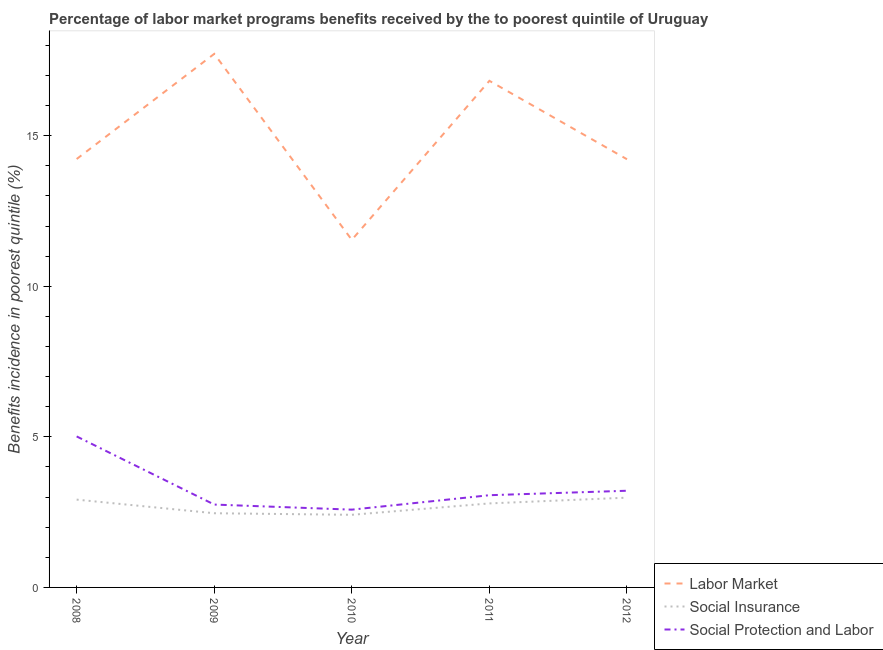How many different coloured lines are there?
Offer a terse response. 3. Does the line corresponding to percentage of benefits received due to labor market programs intersect with the line corresponding to percentage of benefits received due to social insurance programs?
Provide a succinct answer. No. What is the percentage of benefits received due to labor market programs in 2009?
Make the answer very short. 17.72. Across all years, what is the maximum percentage of benefits received due to social protection programs?
Give a very brief answer. 5.02. Across all years, what is the minimum percentage of benefits received due to labor market programs?
Your response must be concise. 11.54. What is the total percentage of benefits received due to labor market programs in the graph?
Make the answer very short. 74.54. What is the difference between the percentage of benefits received due to social insurance programs in 2009 and that in 2012?
Make the answer very short. -0.52. What is the difference between the percentage of benefits received due to labor market programs in 2008 and the percentage of benefits received due to social insurance programs in 2009?
Offer a very short reply. 11.76. What is the average percentage of benefits received due to social protection programs per year?
Your answer should be very brief. 3.32. In the year 2012, what is the difference between the percentage of benefits received due to social protection programs and percentage of benefits received due to labor market programs?
Provide a succinct answer. -11.01. In how many years, is the percentage of benefits received due to social protection programs greater than 16 %?
Offer a very short reply. 0. What is the ratio of the percentage of benefits received due to social insurance programs in 2008 to that in 2011?
Your answer should be very brief. 1.05. Is the difference between the percentage of benefits received due to social insurance programs in 2010 and 2011 greater than the difference between the percentage of benefits received due to social protection programs in 2010 and 2011?
Offer a terse response. Yes. What is the difference between the highest and the second highest percentage of benefits received due to social insurance programs?
Provide a succinct answer. 0.07. What is the difference between the highest and the lowest percentage of benefits received due to social protection programs?
Provide a succinct answer. 2.43. How many lines are there?
Keep it short and to the point. 3. What is the difference between two consecutive major ticks on the Y-axis?
Offer a terse response. 5. Does the graph contain any zero values?
Make the answer very short. No. Does the graph contain grids?
Ensure brevity in your answer.  No. Where does the legend appear in the graph?
Provide a succinct answer. Bottom right. How many legend labels are there?
Keep it short and to the point. 3. How are the legend labels stacked?
Your answer should be very brief. Vertical. What is the title of the graph?
Ensure brevity in your answer.  Percentage of labor market programs benefits received by the to poorest quintile of Uruguay. Does "Taxes on income" appear as one of the legend labels in the graph?
Give a very brief answer. No. What is the label or title of the Y-axis?
Make the answer very short. Benefits incidence in poorest quintile (%). What is the Benefits incidence in poorest quintile (%) in Labor Market in 2008?
Your response must be concise. 14.23. What is the Benefits incidence in poorest quintile (%) of Social Insurance in 2008?
Your answer should be compact. 2.92. What is the Benefits incidence in poorest quintile (%) in Social Protection and Labor in 2008?
Offer a terse response. 5.02. What is the Benefits incidence in poorest quintile (%) in Labor Market in 2009?
Offer a very short reply. 17.72. What is the Benefits incidence in poorest quintile (%) in Social Insurance in 2009?
Keep it short and to the point. 2.46. What is the Benefits incidence in poorest quintile (%) of Social Protection and Labor in 2009?
Offer a very short reply. 2.75. What is the Benefits incidence in poorest quintile (%) in Labor Market in 2010?
Your response must be concise. 11.54. What is the Benefits incidence in poorest quintile (%) of Social Insurance in 2010?
Ensure brevity in your answer.  2.41. What is the Benefits incidence in poorest quintile (%) in Social Protection and Labor in 2010?
Your answer should be very brief. 2.58. What is the Benefits incidence in poorest quintile (%) of Labor Market in 2011?
Your answer should be compact. 16.82. What is the Benefits incidence in poorest quintile (%) of Social Insurance in 2011?
Offer a very short reply. 2.79. What is the Benefits incidence in poorest quintile (%) of Social Protection and Labor in 2011?
Ensure brevity in your answer.  3.06. What is the Benefits incidence in poorest quintile (%) of Labor Market in 2012?
Keep it short and to the point. 14.22. What is the Benefits incidence in poorest quintile (%) in Social Insurance in 2012?
Provide a short and direct response. 2.98. What is the Benefits incidence in poorest quintile (%) in Social Protection and Labor in 2012?
Your answer should be compact. 3.21. Across all years, what is the maximum Benefits incidence in poorest quintile (%) in Labor Market?
Ensure brevity in your answer.  17.72. Across all years, what is the maximum Benefits incidence in poorest quintile (%) of Social Insurance?
Make the answer very short. 2.98. Across all years, what is the maximum Benefits incidence in poorest quintile (%) in Social Protection and Labor?
Provide a short and direct response. 5.02. Across all years, what is the minimum Benefits incidence in poorest quintile (%) in Labor Market?
Ensure brevity in your answer.  11.54. Across all years, what is the minimum Benefits incidence in poorest quintile (%) in Social Insurance?
Offer a terse response. 2.41. Across all years, what is the minimum Benefits incidence in poorest quintile (%) of Social Protection and Labor?
Give a very brief answer. 2.58. What is the total Benefits incidence in poorest quintile (%) of Labor Market in the graph?
Offer a very short reply. 74.54. What is the total Benefits incidence in poorest quintile (%) in Social Insurance in the graph?
Give a very brief answer. 13.56. What is the total Benefits incidence in poorest quintile (%) of Social Protection and Labor in the graph?
Your response must be concise. 16.62. What is the difference between the Benefits incidence in poorest quintile (%) of Labor Market in 2008 and that in 2009?
Offer a terse response. -3.49. What is the difference between the Benefits incidence in poorest quintile (%) in Social Insurance in 2008 and that in 2009?
Make the answer very short. 0.45. What is the difference between the Benefits incidence in poorest quintile (%) of Social Protection and Labor in 2008 and that in 2009?
Give a very brief answer. 2.26. What is the difference between the Benefits incidence in poorest quintile (%) of Labor Market in 2008 and that in 2010?
Offer a terse response. 2.68. What is the difference between the Benefits incidence in poorest quintile (%) of Social Insurance in 2008 and that in 2010?
Ensure brevity in your answer.  0.5. What is the difference between the Benefits incidence in poorest quintile (%) of Social Protection and Labor in 2008 and that in 2010?
Your response must be concise. 2.43. What is the difference between the Benefits incidence in poorest quintile (%) of Labor Market in 2008 and that in 2011?
Provide a short and direct response. -2.6. What is the difference between the Benefits incidence in poorest quintile (%) in Social Insurance in 2008 and that in 2011?
Make the answer very short. 0.13. What is the difference between the Benefits incidence in poorest quintile (%) in Social Protection and Labor in 2008 and that in 2011?
Your answer should be very brief. 1.95. What is the difference between the Benefits incidence in poorest quintile (%) of Labor Market in 2008 and that in 2012?
Offer a terse response. 0.01. What is the difference between the Benefits incidence in poorest quintile (%) in Social Insurance in 2008 and that in 2012?
Provide a succinct answer. -0.07. What is the difference between the Benefits incidence in poorest quintile (%) in Social Protection and Labor in 2008 and that in 2012?
Ensure brevity in your answer.  1.8. What is the difference between the Benefits incidence in poorest quintile (%) of Labor Market in 2009 and that in 2010?
Your answer should be very brief. 6.18. What is the difference between the Benefits incidence in poorest quintile (%) of Social Insurance in 2009 and that in 2010?
Offer a very short reply. 0.05. What is the difference between the Benefits incidence in poorest quintile (%) in Social Protection and Labor in 2009 and that in 2010?
Offer a very short reply. 0.17. What is the difference between the Benefits incidence in poorest quintile (%) in Labor Market in 2009 and that in 2011?
Ensure brevity in your answer.  0.9. What is the difference between the Benefits incidence in poorest quintile (%) of Social Insurance in 2009 and that in 2011?
Provide a short and direct response. -0.33. What is the difference between the Benefits incidence in poorest quintile (%) of Social Protection and Labor in 2009 and that in 2011?
Your answer should be compact. -0.31. What is the difference between the Benefits incidence in poorest quintile (%) of Labor Market in 2009 and that in 2012?
Ensure brevity in your answer.  3.5. What is the difference between the Benefits incidence in poorest quintile (%) of Social Insurance in 2009 and that in 2012?
Provide a short and direct response. -0.52. What is the difference between the Benefits incidence in poorest quintile (%) in Social Protection and Labor in 2009 and that in 2012?
Provide a short and direct response. -0.46. What is the difference between the Benefits incidence in poorest quintile (%) in Labor Market in 2010 and that in 2011?
Provide a succinct answer. -5.28. What is the difference between the Benefits incidence in poorest quintile (%) of Social Insurance in 2010 and that in 2011?
Offer a terse response. -0.38. What is the difference between the Benefits incidence in poorest quintile (%) in Social Protection and Labor in 2010 and that in 2011?
Offer a terse response. -0.48. What is the difference between the Benefits incidence in poorest quintile (%) in Labor Market in 2010 and that in 2012?
Give a very brief answer. -2.68. What is the difference between the Benefits incidence in poorest quintile (%) in Social Insurance in 2010 and that in 2012?
Provide a succinct answer. -0.57. What is the difference between the Benefits incidence in poorest quintile (%) of Social Protection and Labor in 2010 and that in 2012?
Your response must be concise. -0.63. What is the difference between the Benefits incidence in poorest quintile (%) of Labor Market in 2011 and that in 2012?
Provide a succinct answer. 2.6. What is the difference between the Benefits incidence in poorest quintile (%) of Social Insurance in 2011 and that in 2012?
Your answer should be very brief. -0.19. What is the difference between the Benefits incidence in poorest quintile (%) in Social Protection and Labor in 2011 and that in 2012?
Your answer should be compact. -0.15. What is the difference between the Benefits incidence in poorest quintile (%) in Labor Market in 2008 and the Benefits incidence in poorest quintile (%) in Social Insurance in 2009?
Provide a short and direct response. 11.76. What is the difference between the Benefits incidence in poorest quintile (%) of Labor Market in 2008 and the Benefits incidence in poorest quintile (%) of Social Protection and Labor in 2009?
Keep it short and to the point. 11.48. What is the difference between the Benefits incidence in poorest quintile (%) of Social Insurance in 2008 and the Benefits incidence in poorest quintile (%) of Social Protection and Labor in 2009?
Your answer should be compact. 0.16. What is the difference between the Benefits incidence in poorest quintile (%) in Labor Market in 2008 and the Benefits incidence in poorest quintile (%) in Social Insurance in 2010?
Provide a succinct answer. 11.82. What is the difference between the Benefits incidence in poorest quintile (%) in Labor Market in 2008 and the Benefits incidence in poorest quintile (%) in Social Protection and Labor in 2010?
Give a very brief answer. 11.64. What is the difference between the Benefits incidence in poorest quintile (%) in Social Insurance in 2008 and the Benefits incidence in poorest quintile (%) in Social Protection and Labor in 2010?
Keep it short and to the point. 0.33. What is the difference between the Benefits incidence in poorest quintile (%) in Labor Market in 2008 and the Benefits incidence in poorest quintile (%) in Social Insurance in 2011?
Your answer should be very brief. 11.44. What is the difference between the Benefits incidence in poorest quintile (%) of Labor Market in 2008 and the Benefits incidence in poorest quintile (%) of Social Protection and Labor in 2011?
Your answer should be very brief. 11.17. What is the difference between the Benefits incidence in poorest quintile (%) of Social Insurance in 2008 and the Benefits incidence in poorest quintile (%) of Social Protection and Labor in 2011?
Your answer should be very brief. -0.15. What is the difference between the Benefits incidence in poorest quintile (%) of Labor Market in 2008 and the Benefits incidence in poorest quintile (%) of Social Insurance in 2012?
Your answer should be compact. 11.25. What is the difference between the Benefits incidence in poorest quintile (%) of Labor Market in 2008 and the Benefits incidence in poorest quintile (%) of Social Protection and Labor in 2012?
Provide a succinct answer. 11.02. What is the difference between the Benefits incidence in poorest quintile (%) of Social Insurance in 2008 and the Benefits incidence in poorest quintile (%) of Social Protection and Labor in 2012?
Your response must be concise. -0.29. What is the difference between the Benefits incidence in poorest quintile (%) of Labor Market in 2009 and the Benefits incidence in poorest quintile (%) of Social Insurance in 2010?
Give a very brief answer. 15.31. What is the difference between the Benefits incidence in poorest quintile (%) of Labor Market in 2009 and the Benefits incidence in poorest quintile (%) of Social Protection and Labor in 2010?
Your answer should be compact. 15.14. What is the difference between the Benefits incidence in poorest quintile (%) in Social Insurance in 2009 and the Benefits incidence in poorest quintile (%) in Social Protection and Labor in 2010?
Offer a terse response. -0.12. What is the difference between the Benefits incidence in poorest quintile (%) of Labor Market in 2009 and the Benefits incidence in poorest quintile (%) of Social Insurance in 2011?
Offer a terse response. 14.93. What is the difference between the Benefits incidence in poorest quintile (%) in Labor Market in 2009 and the Benefits incidence in poorest quintile (%) in Social Protection and Labor in 2011?
Your answer should be very brief. 14.66. What is the difference between the Benefits incidence in poorest quintile (%) in Social Insurance in 2009 and the Benefits incidence in poorest quintile (%) in Social Protection and Labor in 2011?
Your answer should be very brief. -0.6. What is the difference between the Benefits incidence in poorest quintile (%) in Labor Market in 2009 and the Benefits incidence in poorest quintile (%) in Social Insurance in 2012?
Offer a terse response. 14.74. What is the difference between the Benefits incidence in poorest quintile (%) in Labor Market in 2009 and the Benefits incidence in poorest quintile (%) in Social Protection and Labor in 2012?
Provide a short and direct response. 14.51. What is the difference between the Benefits incidence in poorest quintile (%) in Social Insurance in 2009 and the Benefits incidence in poorest quintile (%) in Social Protection and Labor in 2012?
Provide a short and direct response. -0.75. What is the difference between the Benefits incidence in poorest quintile (%) in Labor Market in 2010 and the Benefits incidence in poorest quintile (%) in Social Insurance in 2011?
Offer a very short reply. 8.75. What is the difference between the Benefits incidence in poorest quintile (%) in Labor Market in 2010 and the Benefits incidence in poorest quintile (%) in Social Protection and Labor in 2011?
Provide a succinct answer. 8.48. What is the difference between the Benefits incidence in poorest quintile (%) in Social Insurance in 2010 and the Benefits incidence in poorest quintile (%) in Social Protection and Labor in 2011?
Provide a succinct answer. -0.65. What is the difference between the Benefits incidence in poorest quintile (%) in Labor Market in 2010 and the Benefits incidence in poorest quintile (%) in Social Insurance in 2012?
Make the answer very short. 8.56. What is the difference between the Benefits incidence in poorest quintile (%) in Labor Market in 2010 and the Benefits incidence in poorest quintile (%) in Social Protection and Labor in 2012?
Provide a succinct answer. 8.33. What is the difference between the Benefits incidence in poorest quintile (%) in Social Insurance in 2010 and the Benefits incidence in poorest quintile (%) in Social Protection and Labor in 2012?
Your answer should be compact. -0.8. What is the difference between the Benefits incidence in poorest quintile (%) in Labor Market in 2011 and the Benefits incidence in poorest quintile (%) in Social Insurance in 2012?
Your response must be concise. 13.84. What is the difference between the Benefits incidence in poorest quintile (%) in Labor Market in 2011 and the Benefits incidence in poorest quintile (%) in Social Protection and Labor in 2012?
Ensure brevity in your answer.  13.61. What is the difference between the Benefits incidence in poorest quintile (%) in Social Insurance in 2011 and the Benefits incidence in poorest quintile (%) in Social Protection and Labor in 2012?
Your answer should be very brief. -0.42. What is the average Benefits incidence in poorest quintile (%) in Labor Market per year?
Make the answer very short. 14.91. What is the average Benefits incidence in poorest quintile (%) in Social Insurance per year?
Give a very brief answer. 2.71. What is the average Benefits incidence in poorest quintile (%) of Social Protection and Labor per year?
Offer a terse response. 3.32. In the year 2008, what is the difference between the Benefits incidence in poorest quintile (%) in Labor Market and Benefits incidence in poorest quintile (%) in Social Insurance?
Your response must be concise. 11.31. In the year 2008, what is the difference between the Benefits incidence in poorest quintile (%) of Labor Market and Benefits incidence in poorest quintile (%) of Social Protection and Labor?
Keep it short and to the point. 9.21. In the year 2008, what is the difference between the Benefits incidence in poorest quintile (%) of Social Insurance and Benefits incidence in poorest quintile (%) of Social Protection and Labor?
Offer a very short reply. -2.1. In the year 2009, what is the difference between the Benefits incidence in poorest quintile (%) in Labor Market and Benefits incidence in poorest quintile (%) in Social Insurance?
Provide a short and direct response. 15.26. In the year 2009, what is the difference between the Benefits incidence in poorest quintile (%) in Labor Market and Benefits incidence in poorest quintile (%) in Social Protection and Labor?
Your answer should be very brief. 14.97. In the year 2009, what is the difference between the Benefits incidence in poorest quintile (%) of Social Insurance and Benefits incidence in poorest quintile (%) of Social Protection and Labor?
Offer a terse response. -0.29. In the year 2010, what is the difference between the Benefits incidence in poorest quintile (%) in Labor Market and Benefits incidence in poorest quintile (%) in Social Insurance?
Your answer should be compact. 9.13. In the year 2010, what is the difference between the Benefits incidence in poorest quintile (%) in Labor Market and Benefits incidence in poorest quintile (%) in Social Protection and Labor?
Provide a succinct answer. 8.96. In the year 2010, what is the difference between the Benefits incidence in poorest quintile (%) in Social Insurance and Benefits incidence in poorest quintile (%) in Social Protection and Labor?
Provide a short and direct response. -0.17. In the year 2011, what is the difference between the Benefits incidence in poorest quintile (%) of Labor Market and Benefits incidence in poorest quintile (%) of Social Insurance?
Keep it short and to the point. 14.03. In the year 2011, what is the difference between the Benefits incidence in poorest quintile (%) in Labor Market and Benefits incidence in poorest quintile (%) in Social Protection and Labor?
Provide a short and direct response. 13.76. In the year 2011, what is the difference between the Benefits incidence in poorest quintile (%) in Social Insurance and Benefits incidence in poorest quintile (%) in Social Protection and Labor?
Keep it short and to the point. -0.27. In the year 2012, what is the difference between the Benefits incidence in poorest quintile (%) in Labor Market and Benefits incidence in poorest quintile (%) in Social Insurance?
Ensure brevity in your answer.  11.24. In the year 2012, what is the difference between the Benefits incidence in poorest quintile (%) of Labor Market and Benefits incidence in poorest quintile (%) of Social Protection and Labor?
Ensure brevity in your answer.  11.01. In the year 2012, what is the difference between the Benefits incidence in poorest quintile (%) in Social Insurance and Benefits incidence in poorest quintile (%) in Social Protection and Labor?
Your answer should be compact. -0.23. What is the ratio of the Benefits incidence in poorest quintile (%) of Labor Market in 2008 to that in 2009?
Your response must be concise. 0.8. What is the ratio of the Benefits incidence in poorest quintile (%) of Social Insurance in 2008 to that in 2009?
Give a very brief answer. 1.18. What is the ratio of the Benefits incidence in poorest quintile (%) in Social Protection and Labor in 2008 to that in 2009?
Ensure brevity in your answer.  1.82. What is the ratio of the Benefits incidence in poorest quintile (%) in Labor Market in 2008 to that in 2010?
Offer a terse response. 1.23. What is the ratio of the Benefits incidence in poorest quintile (%) of Social Insurance in 2008 to that in 2010?
Offer a very short reply. 1.21. What is the ratio of the Benefits incidence in poorest quintile (%) in Social Protection and Labor in 2008 to that in 2010?
Offer a very short reply. 1.94. What is the ratio of the Benefits incidence in poorest quintile (%) of Labor Market in 2008 to that in 2011?
Your answer should be compact. 0.85. What is the ratio of the Benefits incidence in poorest quintile (%) in Social Insurance in 2008 to that in 2011?
Make the answer very short. 1.05. What is the ratio of the Benefits incidence in poorest quintile (%) of Social Protection and Labor in 2008 to that in 2011?
Your response must be concise. 1.64. What is the ratio of the Benefits incidence in poorest quintile (%) of Social Insurance in 2008 to that in 2012?
Give a very brief answer. 0.98. What is the ratio of the Benefits incidence in poorest quintile (%) in Social Protection and Labor in 2008 to that in 2012?
Offer a terse response. 1.56. What is the ratio of the Benefits incidence in poorest quintile (%) in Labor Market in 2009 to that in 2010?
Make the answer very short. 1.54. What is the ratio of the Benefits incidence in poorest quintile (%) of Social Insurance in 2009 to that in 2010?
Keep it short and to the point. 1.02. What is the ratio of the Benefits incidence in poorest quintile (%) of Social Protection and Labor in 2009 to that in 2010?
Provide a short and direct response. 1.07. What is the ratio of the Benefits incidence in poorest quintile (%) in Labor Market in 2009 to that in 2011?
Make the answer very short. 1.05. What is the ratio of the Benefits incidence in poorest quintile (%) of Social Insurance in 2009 to that in 2011?
Make the answer very short. 0.88. What is the ratio of the Benefits incidence in poorest quintile (%) in Social Protection and Labor in 2009 to that in 2011?
Offer a very short reply. 0.9. What is the ratio of the Benefits incidence in poorest quintile (%) in Labor Market in 2009 to that in 2012?
Make the answer very short. 1.25. What is the ratio of the Benefits incidence in poorest quintile (%) of Social Insurance in 2009 to that in 2012?
Your answer should be very brief. 0.83. What is the ratio of the Benefits incidence in poorest quintile (%) of Social Protection and Labor in 2009 to that in 2012?
Ensure brevity in your answer.  0.86. What is the ratio of the Benefits incidence in poorest quintile (%) in Labor Market in 2010 to that in 2011?
Make the answer very short. 0.69. What is the ratio of the Benefits incidence in poorest quintile (%) in Social Insurance in 2010 to that in 2011?
Offer a terse response. 0.86. What is the ratio of the Benefits incidence in poorest quintile (%) in Social Protection and Labor in 2010 to that in 2011?
Your answer should be very brief. 0.84. What is the ratio of the Benefits incidence in poorest quintile (%) of Labor Market in 2010 to that in 2012?
Your response must be concise. 0.81. What is the ratio of the Benefits incidence in poorest quintile (%) in Social Insurance in 2010 to that in 2012?
Keep it short and to the point. 0.81. What is the ratio of the Benefits incidence in poorest quintile (%) of Social Protection and Labor in 2010 to that in 2012?
Your answer should be compact. 0.8. What is the ratio of the Benefits incidence in poorest quintile (%) of Labor Market in 2011 to that in 2012?
Give a very brief answer. 1.18. What is the ratio of the Benefits incidence in poorest quintile (%) of Social Insurance in 2011 to that in 2012?
Make the answer very short. 0.94. What is the ratio of the Benefits incidence in poorest quintile (%) in Social Protection and Labor in 2011 to that in 2012?
Keep it short and to the point. 0.95. What is the difference between the highest and the second highest Benefits incidence in poorest quintile (%) in Labor Market?
Ensure brevity in your answer.  0.9. What is the difference between the highest and the second highest Benefits incidence in poorest quintile (%) in Social Insurance?
Ensure brevity in your answer.  0.07. What is the difference between the highest and the second highest Benefits incidence in poorest quintile (%) of Social Protection and Labor?
Give a very brief answer. 1.8. What is the difference between the highest and the lowest Benefits incidence in poorest quintile (%) in Labor Market?
Your answer should be very brief. 6.18. What is the difference between the highest and the lowest Benefits incidence in poorest quintile (%) in Social Insurance?
Your answer should be very brief. 0.57. What is the difference between the highest and the lowest Benefits incidence in poorest quintile (%) in Social Protection and Labor?
Provide a short and direct response. 2.43. 